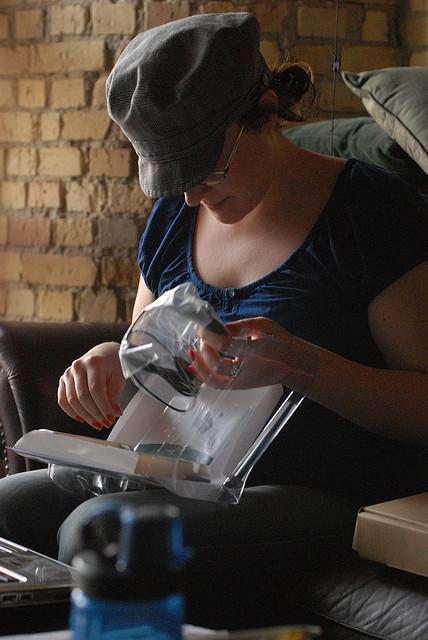How many bottles are there?
Give a very brief answer. 1. How many forks are on the plate?
Give a very brief answer. 0. 